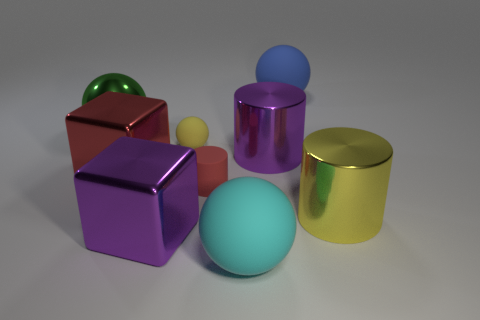How many big shiny cubes are the same color as the matte cylinder?
Give a very brief answer. 1. Is the color of the small ball the same as the large shiny cylinder in front of the purple cylinder?
Your response must be concise. Yes. What is the shape of the big matte object that is behind the yellow object that is behind the big block behind the red cylinder?
Provide a succinct answer. Sphere. What is the shape of the big yellow metal thing?
Your answer should be compact. Cylinder. There is a cylinder on the left side of the purple cylinder; what is its color?
Give a very brief answer. Red. There is a rubber sphere that is to the left of the cyan matte thing; is its size the same as the small red object?
Ensure brevity in your answer.  Yes. The yellow thing that is the same shape as the big cyan object is what size?
Offer a very short reply. Small. Do the red shiny object and the big cyan rubber thing have the same shape?
Keep it short and to the point. No. Is the number of large objects behind the large yellow metal object less than the number of big things in front of the green ball?
Offer a very short reply. Yes. What number of purple things are to the left of the red metallic cube?
Offer a terse response. 0. 